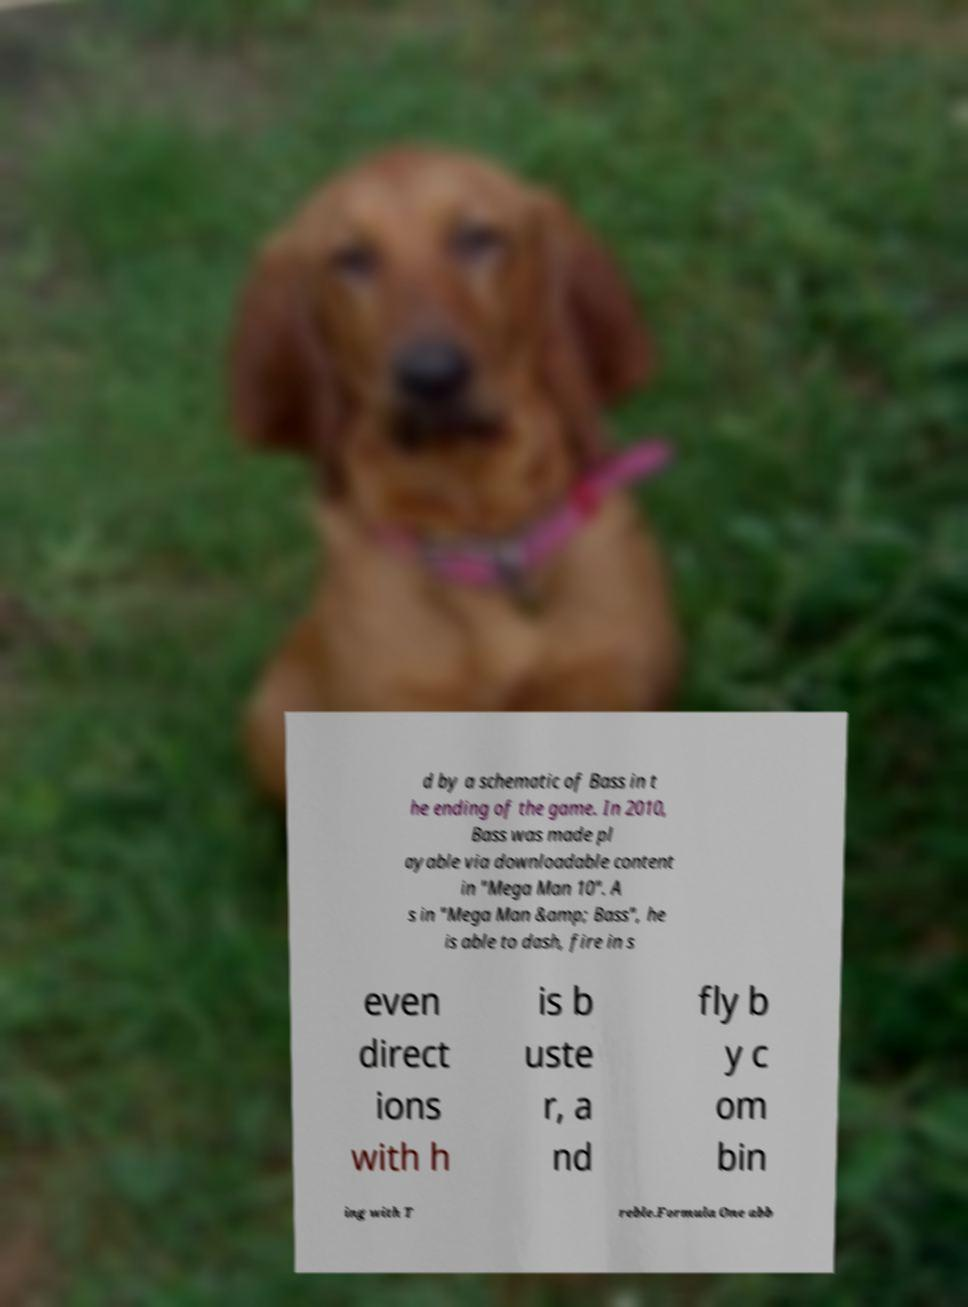Can you read and provide the text displayed in the image?This photo seems to have some interesting text. Can you extract and type it out for me? d by a schematic of Bass in t he ending of the game. In 2010, Bass was made pl ayable via downloadable content in "Mega Man 10". A s in "Mega Man &amp; Bass", he is able to dash, fire in s even direct ions with h is b uste r, a nd fly b y c om bin ing with T reble.Formula One abb 